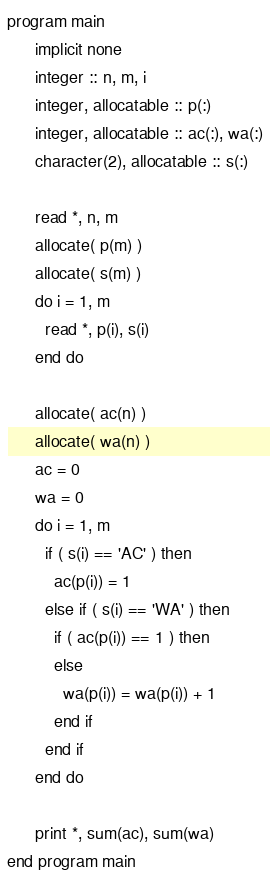<code> <loc_0><loc_0><loc_500><loc_500><_FORTRAN_>program main
      implicit none
      integer :: n, m, i
      integer, allocatable :: p(:)
      integer, allocatable :: ac(:), wa(:)
      character(2), allocatable :: s(:)

      read *, n, m
      allocate( p(m) )
      allocate( s(m) )
      do i = 1, m
        read *, p(i), s(i)
      end do
      
      allocate( ac(n) )
      allocate( wa(n) )
      ac = 0
      wa = 0
      do i = 1, m
        if ( s(i) == 'AC' ) then
          ac(p(i)) = 1
        else if ( s(i) == 'WA' ) then
          if ( ac(p(i)) == 1 ) then
          else
            wa(p(i)) = wa(p(i)) + 1
          end if
        end if
      end do 

      print *, sum(ac), sum(wa)
end program main
</code> 